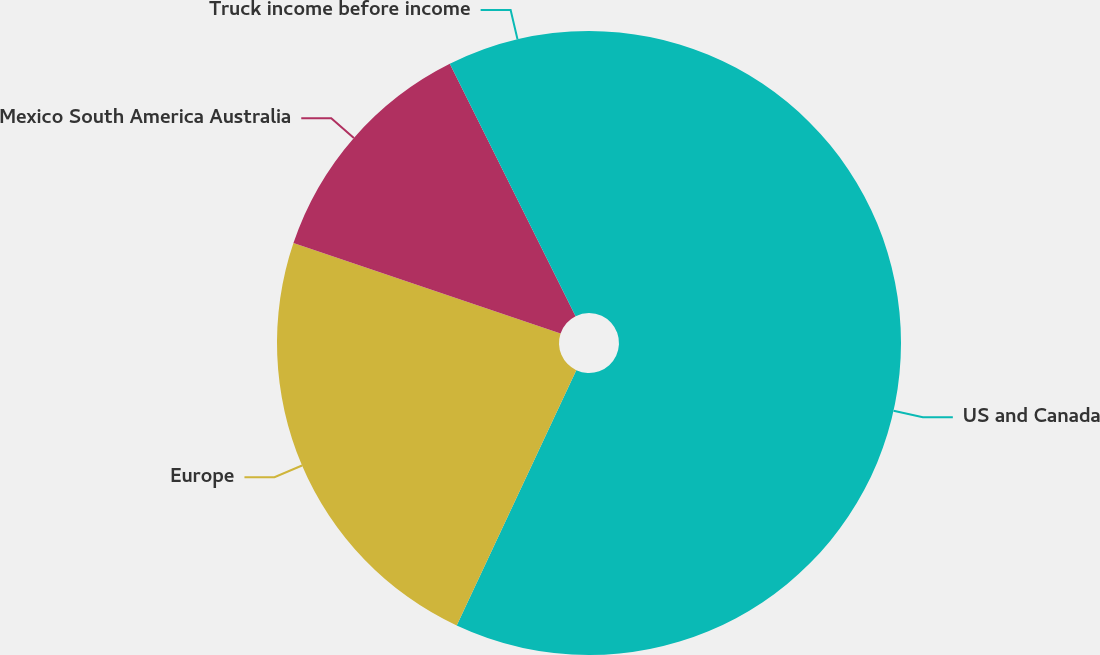Convert chart. <chart><loc_0><loc_0><loc_500><loc_500><pie_chart><fcel>US and Canada<fcel>Europe<fcel>Mexico South America Australia<fcel>Truck income before income<nl><fcel>56.97%<fcel>23.22%<fcel>12.45%<fcel>7.36%<nl></chart> 